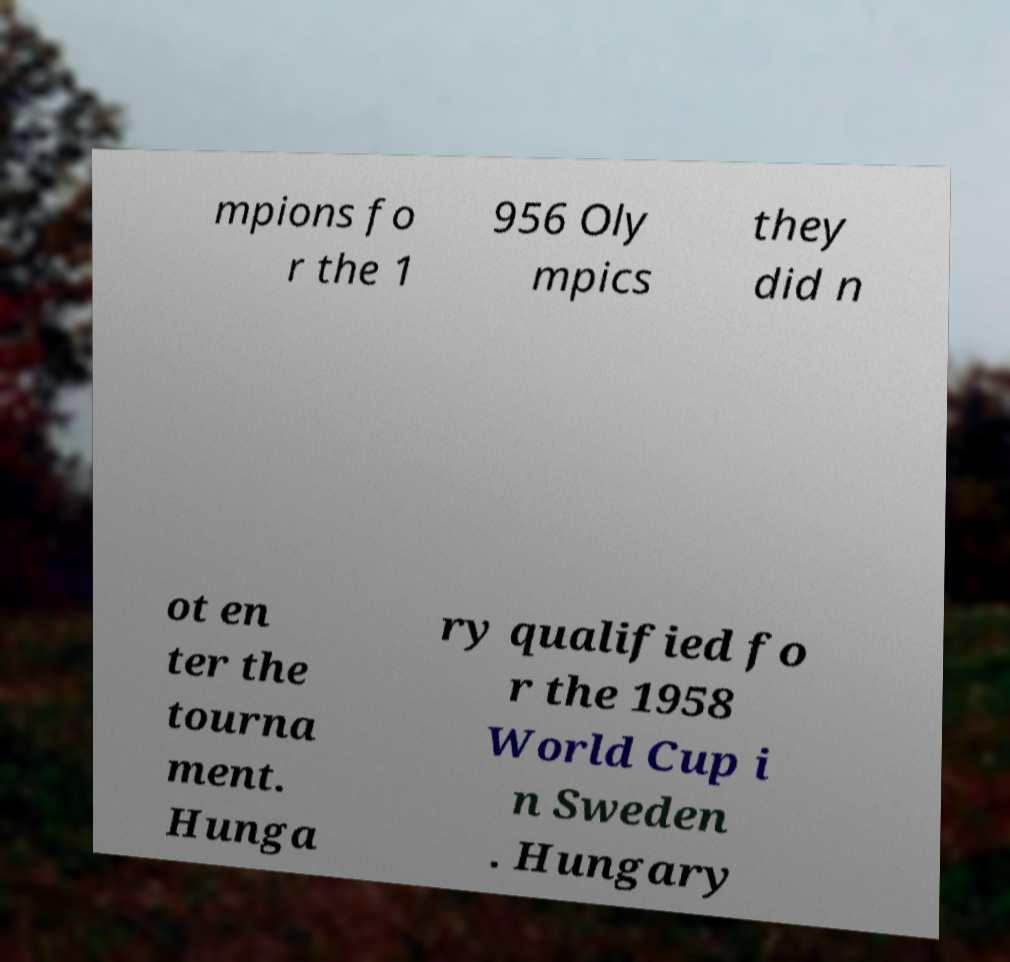I need the written content from this picture converted into text. Can you do that? mpions fo r the 1 956 Oly mpics they did n ot en ter the tourna ment. Hunga ry qualified fo r the 1958 World Cup i n Sweden . Hungary 